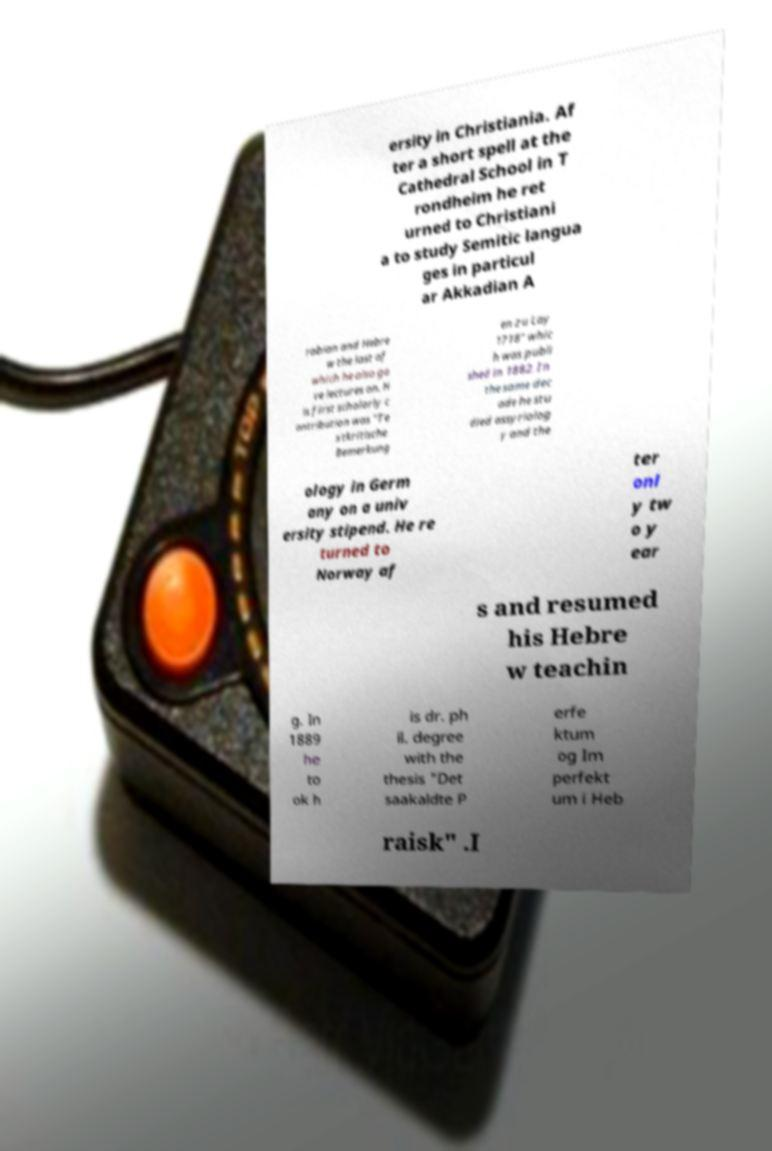Could you assist in decoding the text presented in this image and type it out clearly? ersity in Christiania. Af ter a short spell at the Cathedral School in T rondheim he ret urned to Christiani a to study Semitic langua ges in particul ar Akkadian A rabian and Hebre w the last of which he also ga ve lectures on. H is first scholarly c ontribution was "Te xtkritische Bemerkung en zu Lay 1718" whic h was publi shed in 1882. In the same dec ade he stu died assyriolog y and the ology in Germ any on a univ ersity stipend. He re turned to Norway af ter onl y tw o y ear s and resumed his Hebre w teachin g. In 1889 he to ok h is dr. ph il. degree with the thesis "Det saakaldte P erfe ktum og Im perfekt um i Heb raisk" .I 